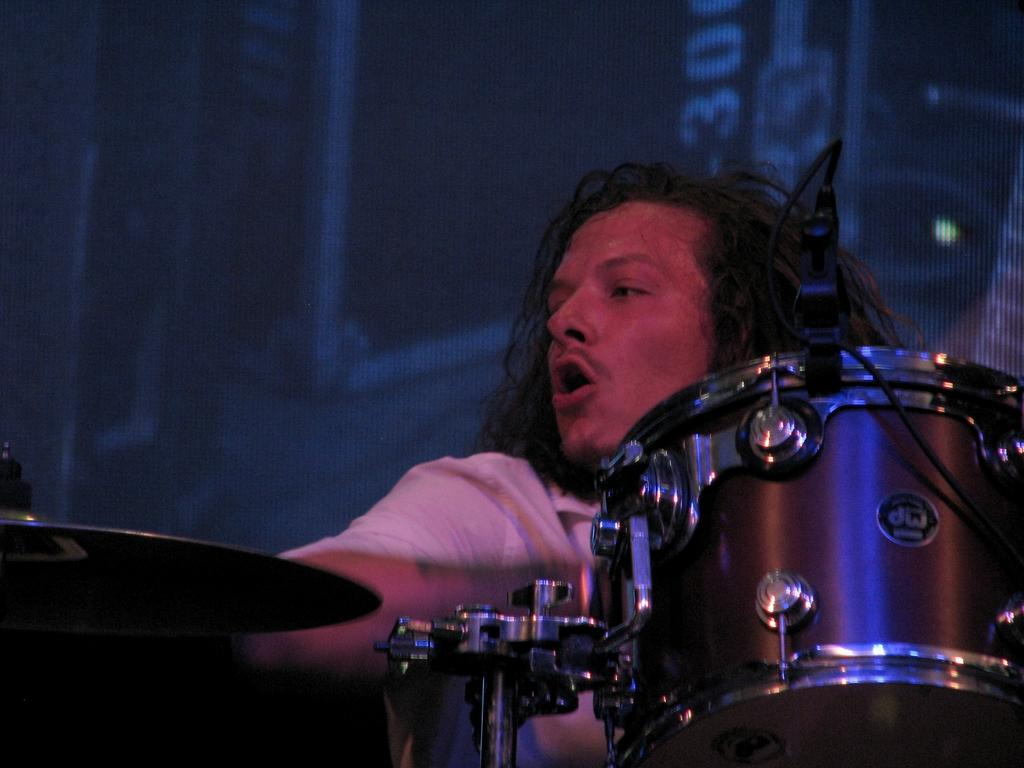Who is the main subject in the image? The main subject in the image is a man. What is the man doing in the image? The man is playing musical instruments in the image. How is the man positioned in the image? The man is sitting on a chair in the image. What is the color of the background in the image? The background of the image is dark. What type of pet does the man have in the image? There is no pet visible in the image. What role does the man play in the image, such as an actor or musician? The man is playing musical instruments in the image, but we cannot determine his role as an actor or musician based solely on the image. 